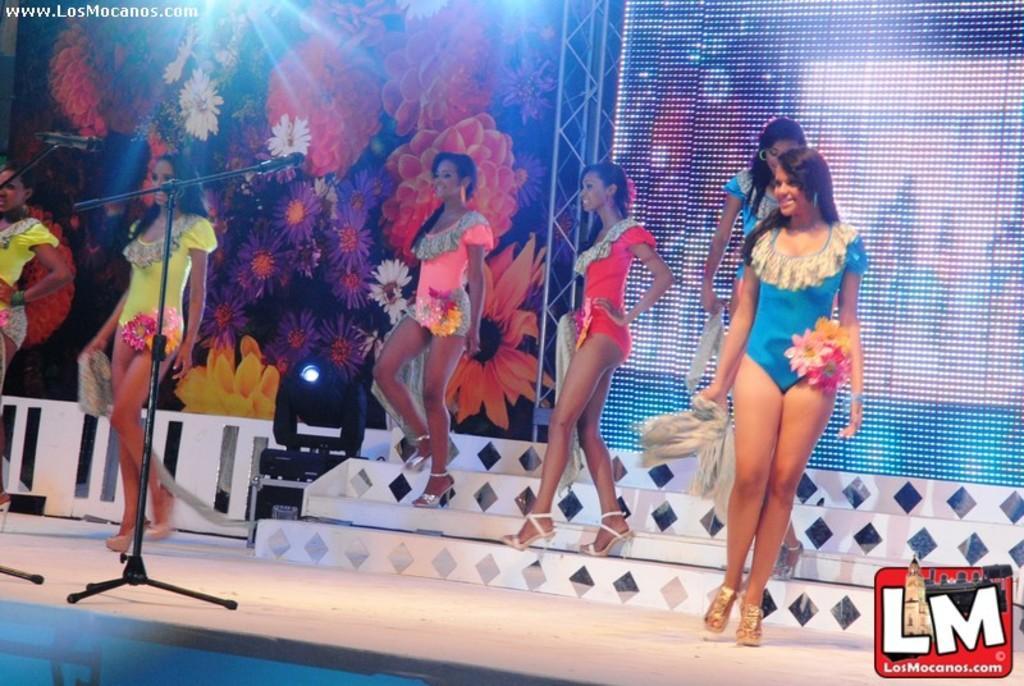Can you describe this image briefly? In this picture we can see some people are walking, on the left side there are microphones, in the background we can see depictions of flowers, there is a light in the middle, we can see a logo and some text at the right bottom. 